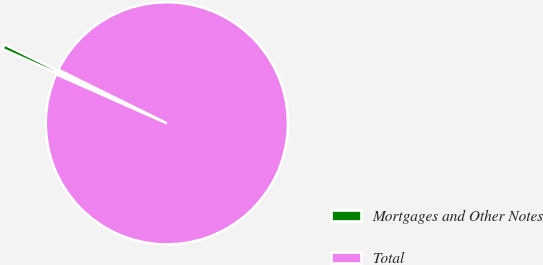<chart> <loc_0><loc_0><loc_500><loc_500><pie_chart><fcel>Mortgages and Other Notes<fcel>Total<nl><fcel>0.66%<fcel>99.34%<nl></chart> 